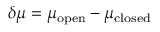Convert formula to latex. <formula><loc_0><loc_0><loc_500><loc_500>\delta \mu = \mu _ { o p e n } - \mu _ { c l o s e d }</formula> 